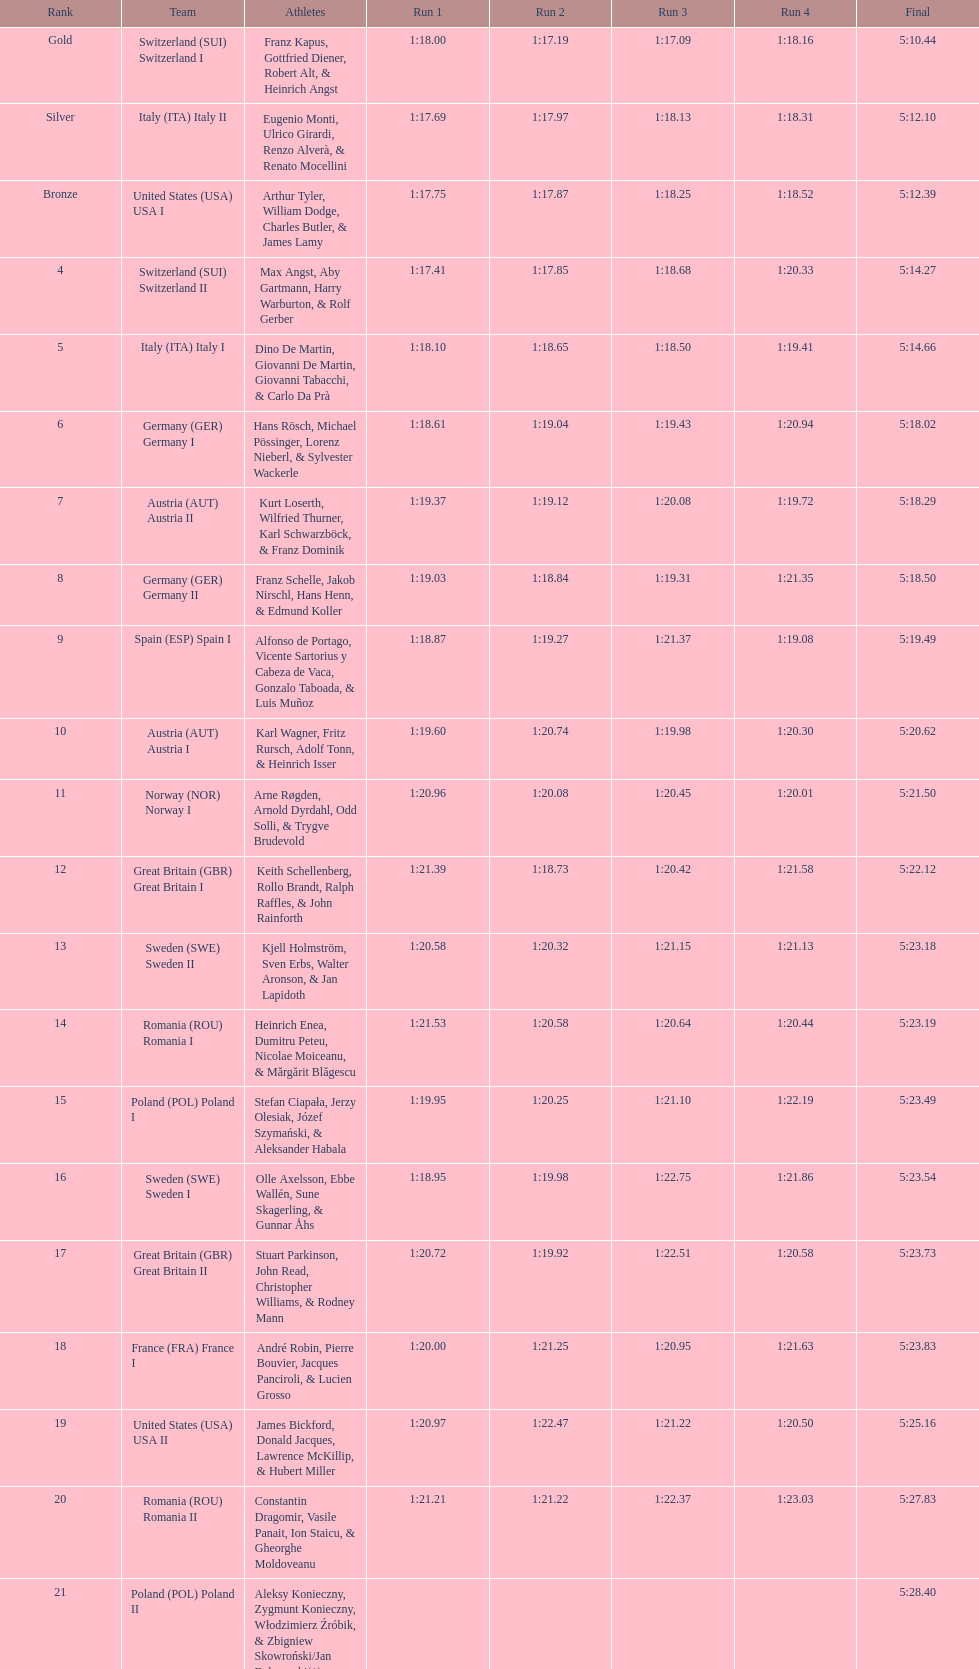What group succeeds italy (ita) italy i? Germany I. 